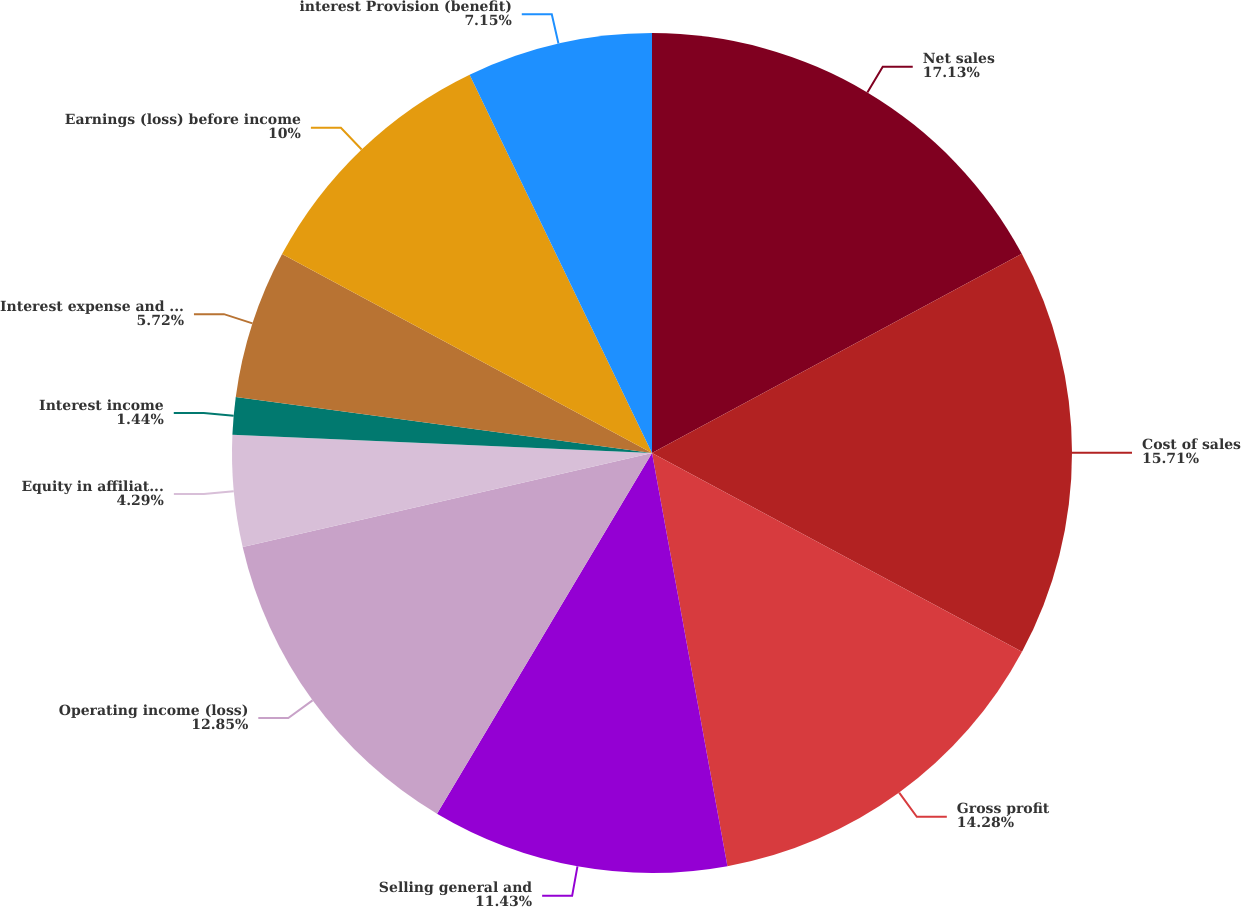Convert chart. <chart><loc_0><loc_0><loc_500><loc_500><pie_chart><fcel>Net sales<fcel>Cost of sales<fcel>Gross profit<fcel>Selling general and<fcel>Operating income (loss)<fcel>Equity in affiliates' earnings<fcel>Interest income<fcel>Interest expense and finance<fcel>Earnings (loss) before income<fcel>interest Provision (benefit)<nl><fcel>17.14%<fcel>15.71%<fcel>14.28%<fcel>11.43%<fcel>12.85%<fcel>4.29%<fcel>1.44%<fcel>5.72%<fcel>10.0%<fcel>7.15%<nl></chart> 